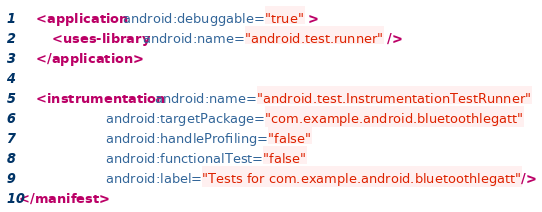Convert code to text. <code><loc_0><loc_0><loc_500><loc_500><_XML_>
    <application android:debuggable="true" >
        <uses-library android:name="android.test.runner" />
    </application>

    <instrumentation android:name="android.test.InstrumentationTestRunner"
                     android:targetPackage="com.example.android.bluetoothlegatt"
                     android:handleProfiling="false"
                     android:functionalTest="false"
                     android:label="Tests for com.example.android.bluetoothlegatt"/>
</manifest>
</code> 